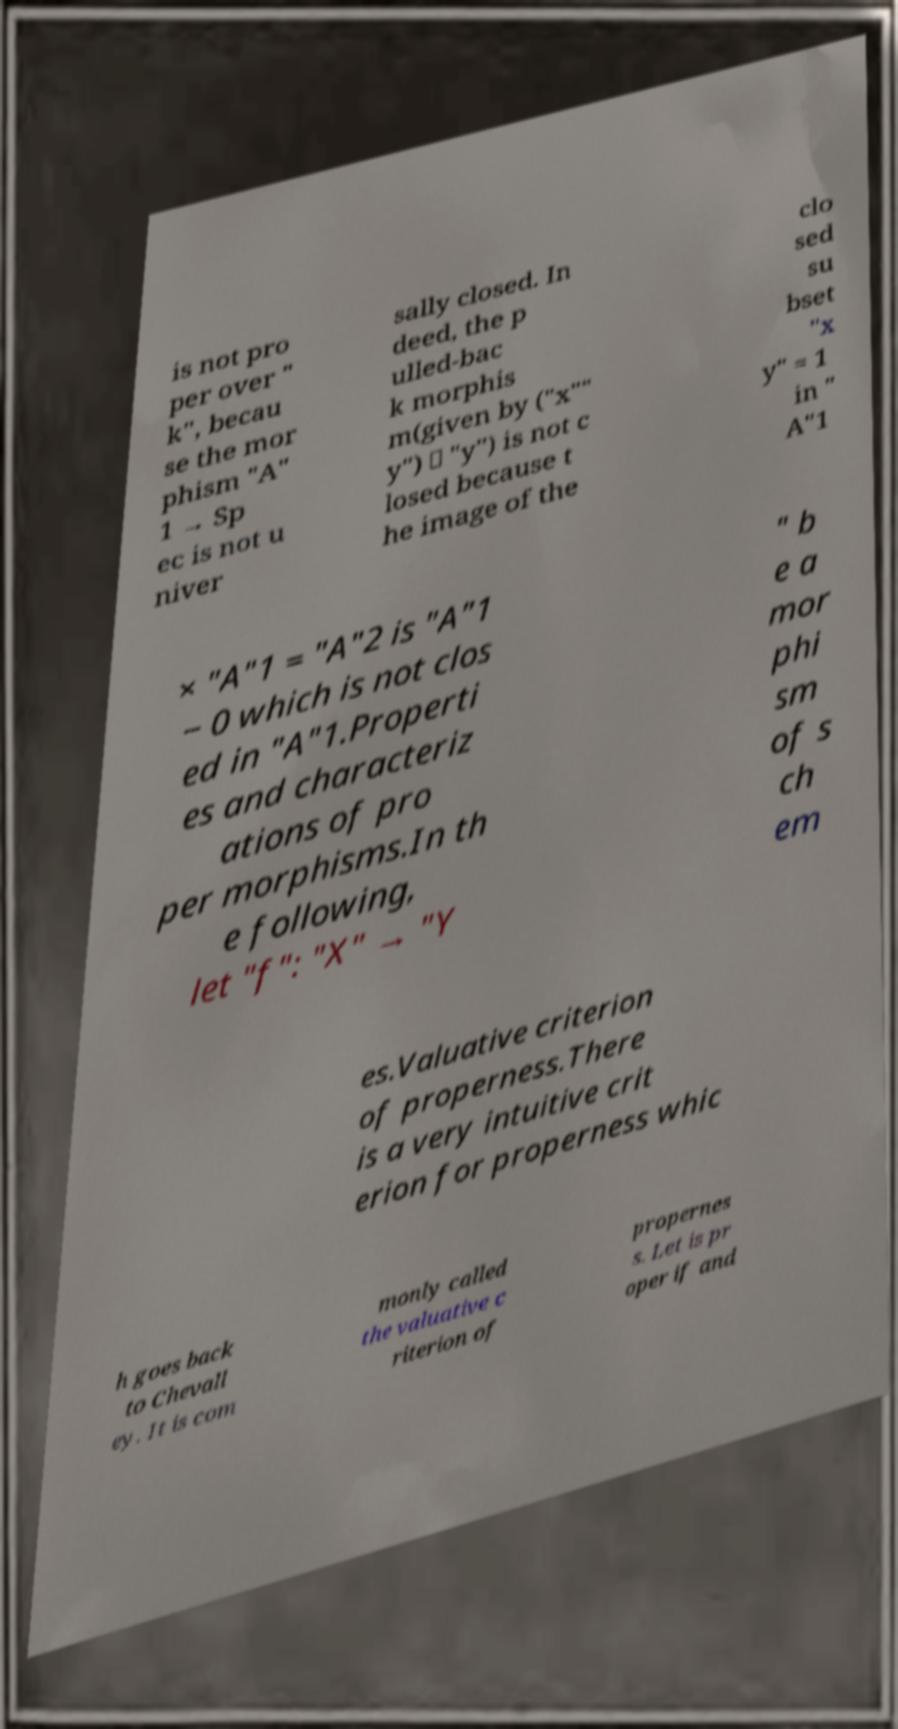For documentation purposes, I need the text within this image transcribed. Could you provide that? is not pro per over " k", becau se the mor phism "A" 1 → Sp ec is not u niver sally closed. In deed, the p ulled-bac k morphis m(given by ("x"" y") ↦ "y") is not c losed because t he image of the clo sed su bset "x y" = 1 in " A"1 × "A"1 = "A"2 is "A"1 − 0 which is not clos ed in "A"1.Properti es and characteriz ations of pro per morphisms.In th e following, let "f": "X" → "Y " b e a mor phi sm of s ch em es.Valuative criterion of properness.There is a very intuitive crit erion for properness whic h goes back to Chevall ey. It is com monly called the valuative c riterion of propernes s. Let is pr oper if and 